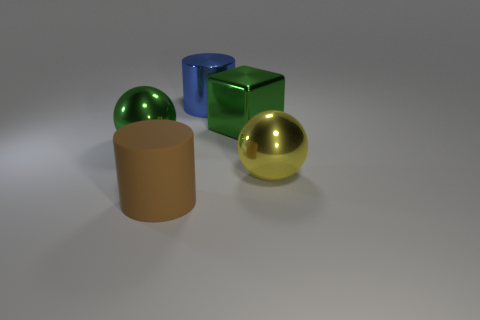Are there any other things that are made of the same material as the large brown thing?
Offer a terse response. No. What size is the cylinder behind the big metal ball on the left side of the metallic sphere that is to the right of the big brown object?
Give a very brief answer. Large. The other object that is the same shape as the yellow object is what color?
Provide a succinct answer. Green. Is the number of green blocks right of the matte cylinder greater than the number of large green shiny spheres?
Provide a succinct answer. No. Do the blue thing and the green metallic object that is on the right side of the blue cylinder have the same shape?
Provide a short and direct response. No. Is there anything else that has the same size as the yellow metal object?
Provide a short and direct response. Yes. What is the size of the blue metallic thing that is the same shape as the matte object?
Give a very brief answer. Large. Are there more big brown matte objects than large red metal cylinders?
Give a very brief answer. Yes. Is the shape of the rubber object the same as the large blue metallic object?
Your answer should be compact. Yes. There is a ball to the left of the green object that is on the right side of the big rubber cylinder; what is it made of?
Provide a succinct answer. Metal. 